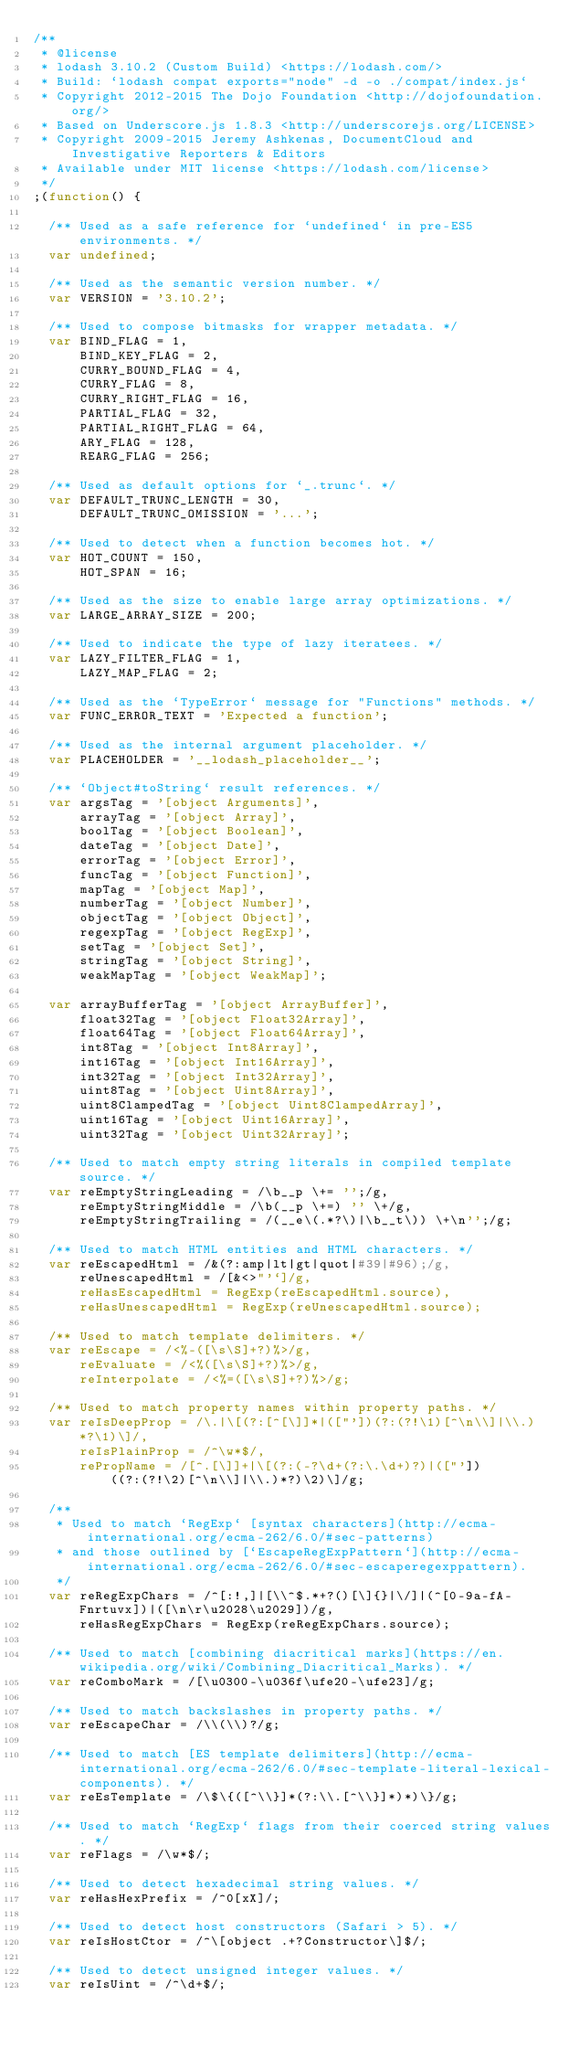Convert code to text. <code><loc_0><loc_0><loc_500><loc_500><_JavaScript_>/**
 * @license
 * lodash 3.10.2 (Custom Build) <https://lodash.com/>
 * Build: `lodash compat exports="node" -d -o ./compat/index.js`
 * Copyright 2012-2015 The Dojo Foundation <http://dojofoundation.org/>
 * Based on Underscore.js 1.8.3 <http://underscorejs.org/LICENSE>
 * Copyright 2009-2015 Jeremy Ashkenas, DocumentCloud and Investigative Reporters & Editors
 * Available under MIT license <https://lodash.com/license>
 */
;(function() {

  /** Used as a safe reference for `undefined` in pre-ES5 environments. */
  var undefined;

  /** Used as the semantic version number. */
  var VERSION = '3.10.2';

  /** Used to compose bitmasks for wrapper metadata. */
  var BIND_FLAG = 1,
      BIND_KEY_FLAG = 2,
      CURRY_BOUND_FLAG = 4,
      CURRY_FLAG = 8,
      CURRY_RIGHT_FLAG = 16,
      PARTIAL_FLAG = 32,
      PARTIAL_RIGHT_FLAG = 64,
      ARY_FLAG = 128,
      REARG_FLAG = 256;

  /** Used as default options for `_.trunc`. */
  var DEFAULT_TRUNC_LENGTH = 30,
      DEFAULT_TRUNC_OMISSION = '...';

  /** Used to detect when a function becomes hot. */
  var HOT_COUNT = 150,
      HOT_SPAN = 16;

  /** Used as the size to enable large array optimizations. */
  var LARGE_ARRAY_SIZE = 200;

  /** Used to indicate the type of lazy iteratees. */
  var LAZY_FILTER_FLAG = 1,
      LAZY_MAP_FLAG = 2;

  /** Used as the `TypeError` message for "Functions" methods. */
  var FUNC_ERROR_TEXT = 'Expected a function';

  /** Used as the internal argument placeholder. */
  var PLACEHOLDER = '__lodash_placeholder__';

  /** `Object#toString` result references. */
  var argsTag = '[object Arguments]',
      arrayTag = '[object Array]',
      boolTag = '[object Boolean]',
      dateTag = '[object Date]',
      errorTag = '[object Error]',
      funcTag = '[object Function]',
      mapTag = '[object Map]',
      numberTag = '[object Number]',
      objectTag = '[object Object]',
      regexpTag = '[object RegExp]',
      setTag = '[object Set]',
      stringTag = '[object String]',
      weakMapTag = '[object WeakMap]';

  var arrayBufferTag = '[object ArrayBuffer]',
      float32Tag = '[object Float32Array]',
      float64Tag = '[object Float64Array]',
      int8Tag = '[object Int8Array]',
      int16Tag = '[object Int16Array]',
      int32Tag = '[object Int32Array]',
      uint8Tag = '[object Uint8Array]',
      uint8ClampedTag = '[object Uint8ClampedArray]',
      uint16Tag = '[object Uint16Array]',
      uint32Tag = '[object Uint32Array]';

  /** Used to match empty string literals in compiled template source. */
  var reEmptyStringLeading = /\b__p \+= '';/g,
      reEmptyStringMiddle = /\b(__p \+=) '' \+/g,
      reEmptyStringTrailing = /(__e\(.*?\)|\b__t\)) \+\n'';/g;

  /** Used to match HTML entities and HTML characters. */
  var reEscapedHtml = /&(?:amp|lt|gt|quot|#39|#96);/g,
      reUnescapedHtml = /[&<>"'`]/g,
      reHasEscapedHtml = RegExp(reEscapedHtml.source),
      reHasUnescapedHtml = RegExp(reUnescapedHtml.source);

  /** Used to match template delimiters. */
  var reEscape = /<%-([\s\S]+?)%>/g,
      reEvaluate = /<%([\s\S]+?)%>/g,
      reInterpolate = /<%=([\s\S]+?)%>/g;

  /** Used to match property names within property paths. */
  var reIsDeepProp = /\.|\[(?:[^[\]]*|(["'])(?:(?!\1)[^\n\\]|\\.)*?\1)\]/,
      reIsPlainProp = /^\w*$/,
      rePropName = /[^.[\]]+|\[(?:(-?\d+(?:\.\d+)?)|(["'])((?:(?!\2)[^\n\\]|\\.)*?)\2)\]/g;

  /**
   * Used to match `RegExp` [syntax characters](http://ecma-international.org/ecma-262/6.0/#sec-patterns)
   * and those outlined by [`EscapeRegExpPattern`](http://ecma-international.org/ecma-262/6.0/#sec-escaperegexppattern).
   */
  var reRegExpChars = /^[:!,]|[\\^$.*+?()[\]{}|\/]|(^[0-9a-fA-Fnrtuvx])|([\n\r\u2028\u2029])/g,
      reHasRegExpChars = RegExp(reRegExpChars.source);

  /** Used to match [combining diacritical marks](https://en.wikipedia.org/wiki/Combining_Diacritical_Marks). */
  var reComboMark = /[\u0300-\u036f\ufe20-\ufe23]/g;

  /** Used to match backslashes in property paths. */
  var reEscapeChar = /\\(\\)?/g;

  /** Used to match [ES template delimiters](http://ecma-international.org/ecma-262/6.0/#sec-template-literal-lexical-components). */
  var reEsTemplate = /\$\{([^\\}]*(?:\\.[^\\}]*)*)\}/g;

  /** Used to match `RegExp` flags from their coerced string values. */
  var reFlags = /\w*$/;

  /** Used to detect hexadecimal string values. */
  var reHasHexPrefix = /^0[xX]/;

  /** Used to detect host constructors (Safari > 5). */
  var reIsHostCtor = /^\[object .+?Constructor\]$/;

  /** Used to detect unsigned integer values. */
  var reIsUint = /^\d+$/;
</code> 